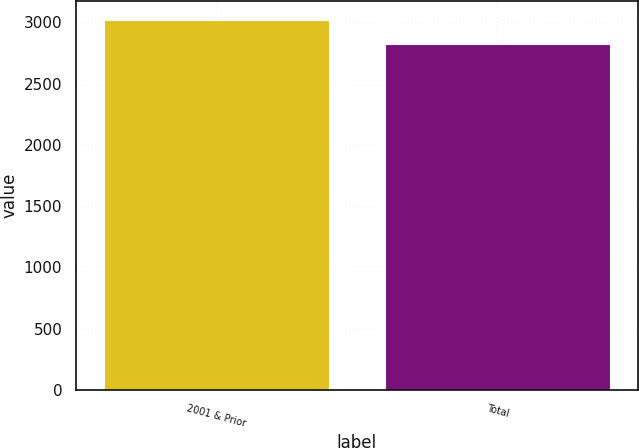<chart> <loc_0><loc_0><loc_500><loc_500><bar_chart><fcel>2001 & Prior<fcel>Total<nl><fcel>3023<fcel>2824<nl></chart> 